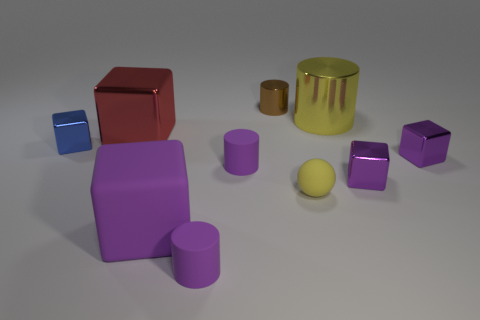Subtract all brown cylinders. How many purple blocks are left? 3 Subtract 2 cubes. How many cubes are left? 3 Subtract all large red blocks. How many blocks are left? 4 Subtract all cyan blocks. Subtract all brown cylinders. How many blocks are left? 5 Subtract all cylinders. How many objects are left? 6 Subtract 0 red cylinders. How many objects are left? 10 Subtract all big red shiny objects. Subtract all shiny cubes. How many objects are left? 5 Add 6 small shiny cubes. How many small shiny cubes are left? 9 Add 8 big yellow rubber spheres. How many big yellow rubber spheres exist? 8 